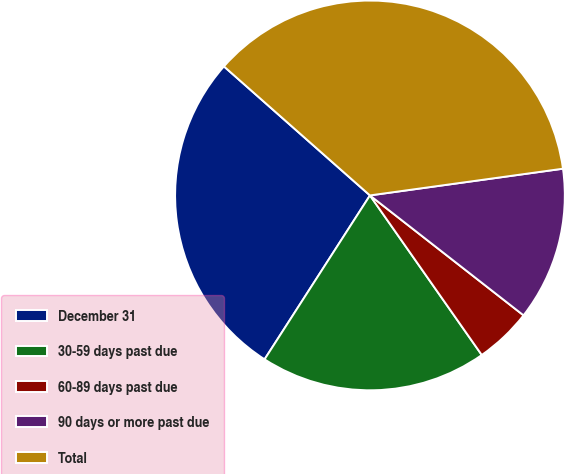Convert chart to OTSL. <chart><loc_0><loc_0><loc_500><loc_500><pie_chart><fcel>December 31<fcel>30-59 days past due<fcel>60-89 days past due<fcel>90 days or more past due<fcel>Total<nl><fcel>27.42%<fcel>18.82%<fcel>4.72%<fcel>12.74%<fcel>36.29%<nl></chart> 